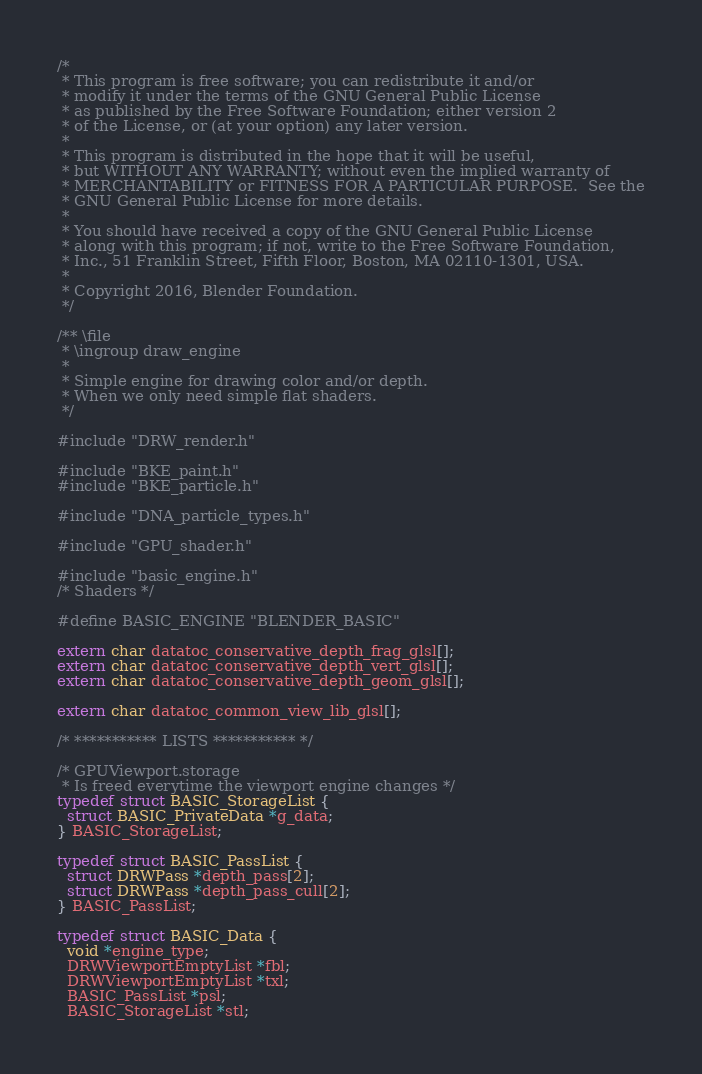Convert code to text. <code><loc_0><loc_0><loc_500><loc_500><_C_>/*
 * This program is free software; you can redistribute it and/or
 * modify it under the terms of the GNU General Public License
 * as published by the Free Software Foundation; either version 2
 * of the License, or (at your option) any later version.
 *
 * This program is distributed in the hope that it will be useful,
 * but WITHOUT ANY WARRANTY; without even the implied warranty of
 * MERCHANTABILITY or FITNESS FOR A PARTICULAR PURPOSE.  See the
 * GNU General Public License for more details.
 *
 * You should have received a copy of the GNU General Public License
 * along with this program; if not, write to the Free Software Foundation,
 * Inc., 51 Franklin Street, Fifth Floor, Boston, MA 02110-1301, USA.
 *
 * Copyright 2016, Blender Foundation.
 */

/** \file
 * \ingroup draw_engine
 *
 * Simple engine for drawing color and/or depth.
 * When we only need simple flat shaders.
 */

#include "DRW_render.h"

#include "BKE_paint.h"
#include "BKE_particle.h"

#include "DNA_particle_types.h"

#include "GPU_shader.h"

#include "basic_engine.h"
/* Shaders */

#define BASIC_ENGINE "BLENDER_BASIC"

extern char datatoc_conservative_depth_frag_glsl[];
extern char datatoc_conservative_depth_vert_glsl[];
extern char datatoc_conservative_depth_geom_glsl[];

extern char datatoc_common_view_lib_glsl[];

/* *********** LISTS *********** */

/* GPUViewport.storage
 * Is freed everytime the viewport engine changes */
typedef struct BASIC_StorageList {
  struct BASIC_PrivateData *g_data;
} BASIC_StorageList;

typedef struct BASIC_PassList {
  struct DRWPass *depth_pass[2];
  struct DRWPass *depth_pass_cull[2];
} BASIC_PassList;

typedef struct BASIC_Data {
  void *engine_type;
  DRWViewportEmptyList *fbl;
  DRWViewportEmptyList *txl;
  BASIC_PassList *psl;
  BASIC_StorageList *stl;</code> 